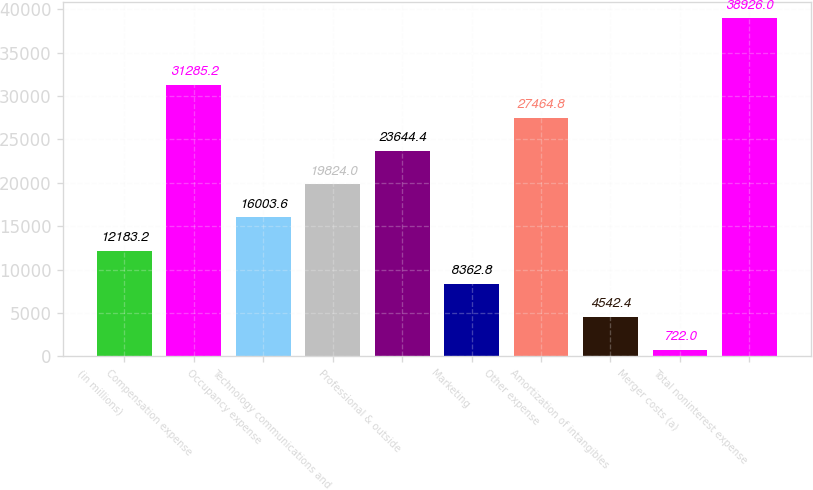Convert chart to OTSL. <chart><loc_0><loc_0><loc_500><loc_500><bar_chart><fcel>(in millions)<fcel>Compensation expense<fcel>Occupancy expense<fcel>Technology communications and<fcel>Professional & outside<fcel>Marketing<fcel>Other expense<fcel>Amortization of intangibles<fcel>Merger costs (a)<fcel>Total noninterest expense<nl><fcel>12183.2<fcel>31285.2<fcel>16003.6<fcel>19824<fcel>23644.4<fcel>8362.8<fcel>27464.8<fcel>4542.4<fcel>722<fcel>38926<nl></chart> 